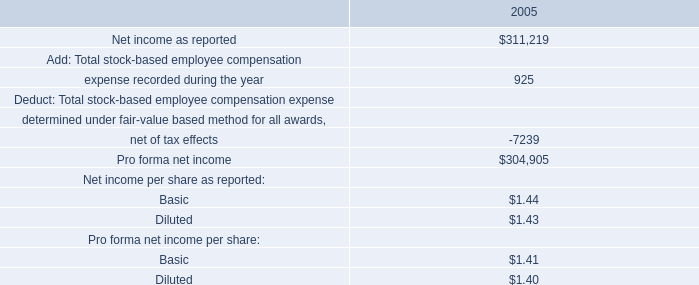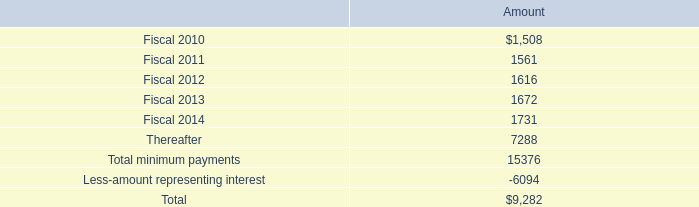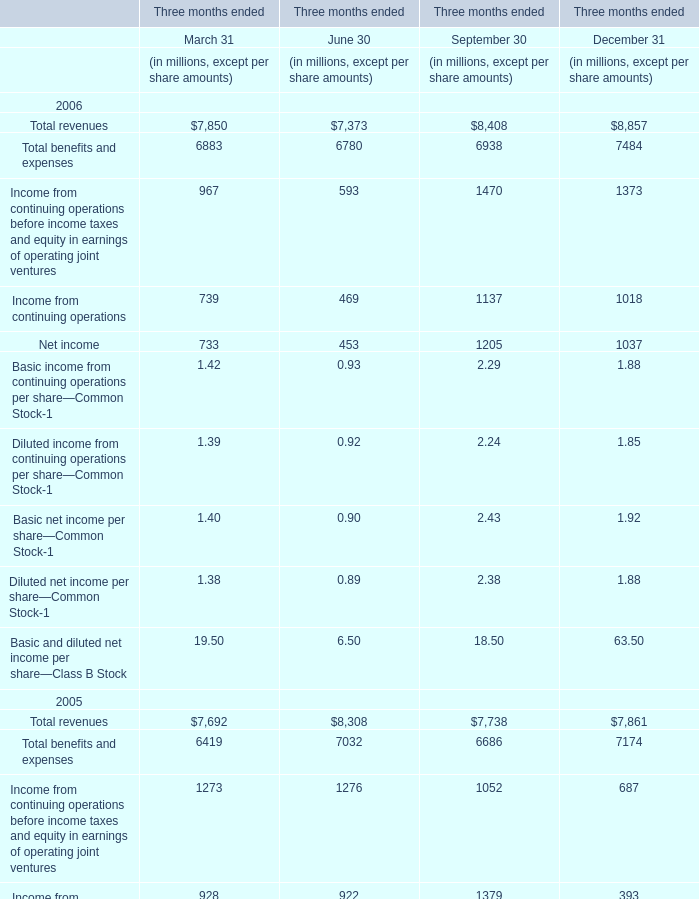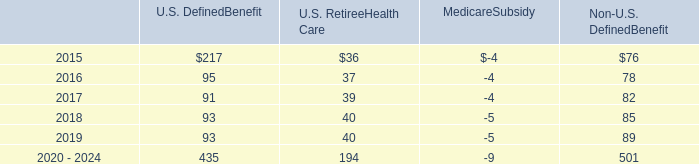Which year is total revenue in September 30 the most? 
Answer: 2006. 